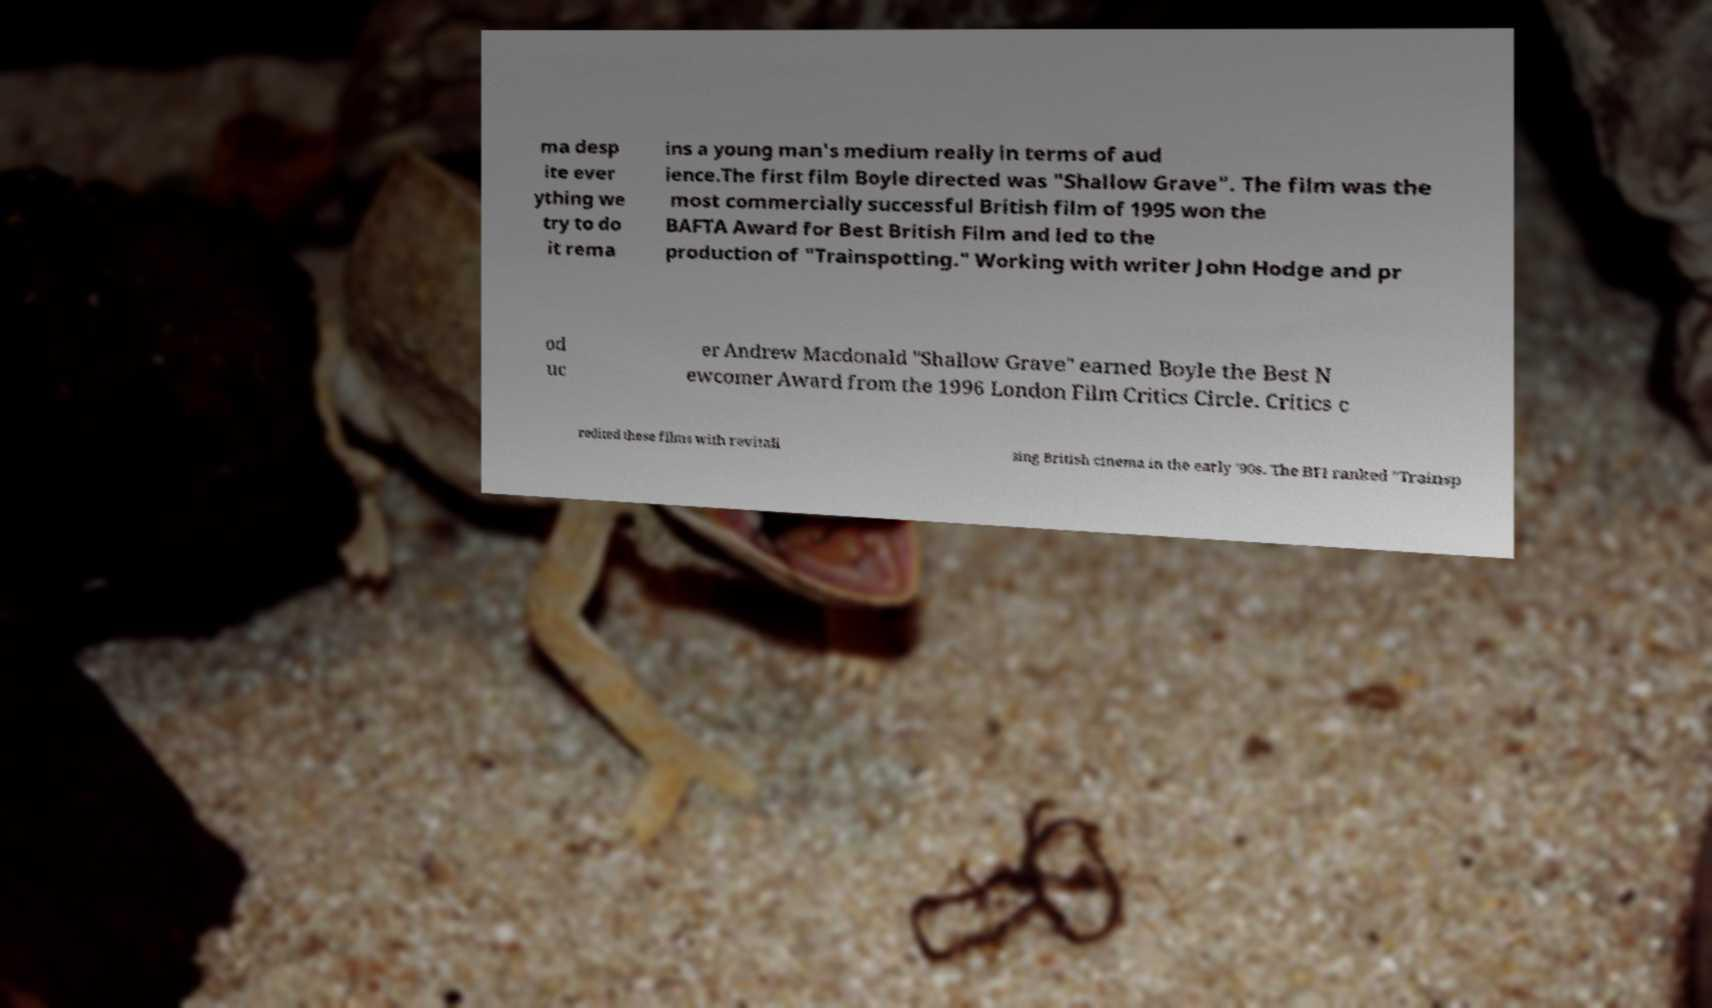Could you extract and type out the text from this image? ma desp ite ever ything we try to do it rema ins a young man's medium really in terms of aud ience.The first film Boyle directed was "Shallow Grave". The film was the most commercially successful British film of 1995 won the BAFTA Award for Best British Film and led to the production of "Trainspotting." Working with writer John Hodge and pr od uc er Andrew Macdonald "Shallow Grave" earned Boyle the Best N ewcomer Award from the 1996 London Film Critics Circle. Critics c redited these films with revitali sing British cinema in the early '90s. The BFI ranked "Trainsp 